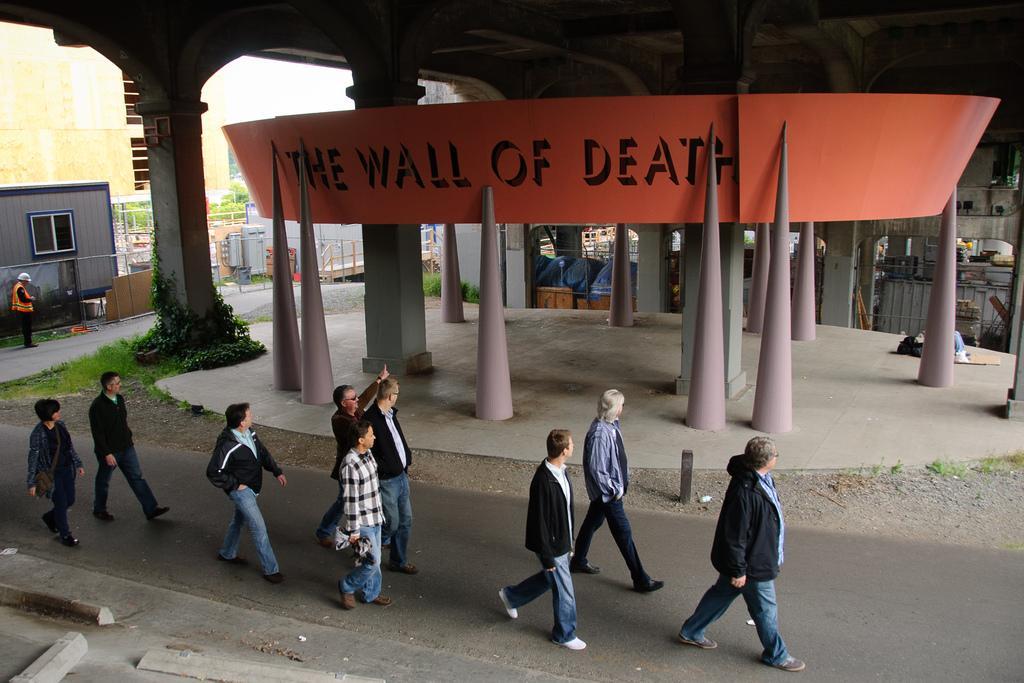Please provide a concise description of this image. In this image there are people walking on a road in the background there are poles and a banner on that banner there is text and plants and sheds. 